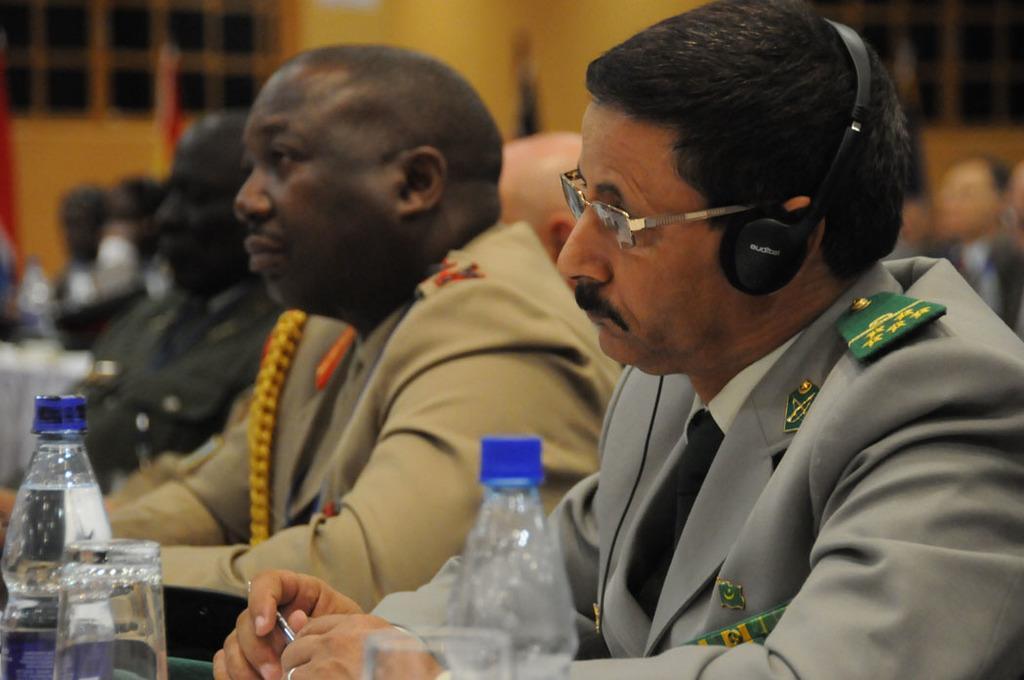Describe this image in one or two sentences. This image is taken inside a room. There are few people sitting on the chairs. In the right side of the image a man is sitting in the chair wearing headphones, spectacles and holding a pen in his hand. In the middle of the image there is a bottle a glass with water in it. In the background there is a wall with door and windows. 